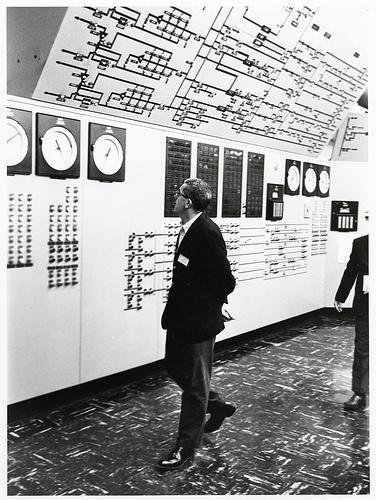How many faces can be seen?
Give a very brief answer. 1. 